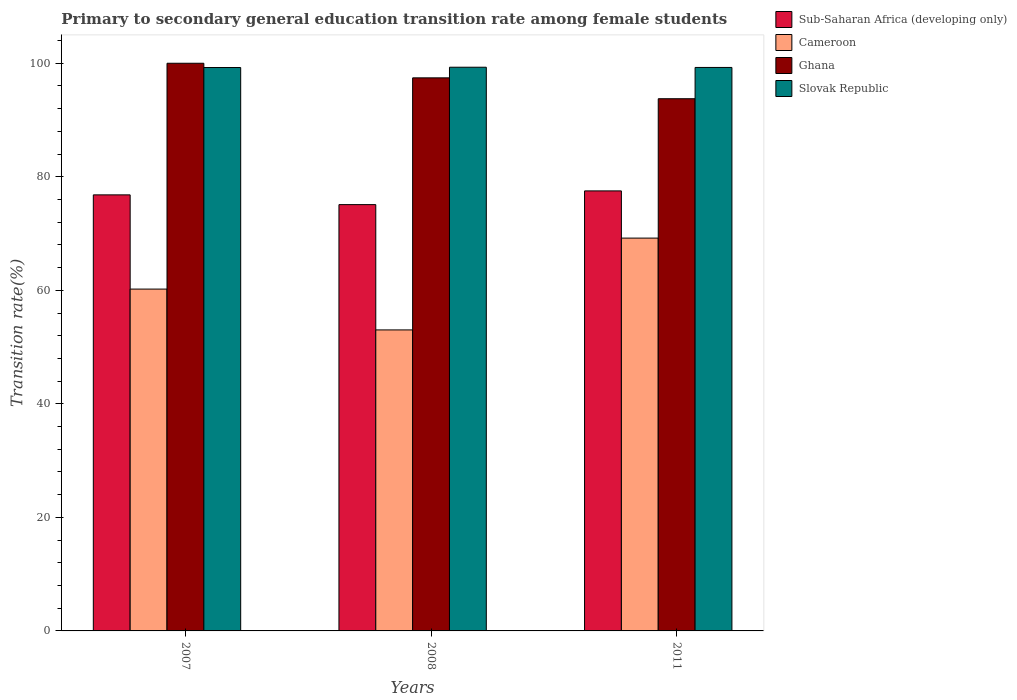How many different coloured bars are there?
Make the answer very short. 4. How many groups of bars are there?
Your answer should be compact. 3. Are the number of bars per tick equal to the number of legend labels?
Ensure brevity in your answer.  Yes. How many bars are there on the 3rd tick from the right?
Offer a very short reply. 4. What is the transition rate in Sub-Saharan Africa (developing only) in 2007?
Give a very brief answer. 76.81. Across all years, what is the maximum transition rate in Cameroon?
Your answer should be very brief. 69.2. Across all years, what is the minimum transition rate in Slovak Republic?
Provide a short and direct response. 99.25. In which year was the transition rate in Sub-Saharan Africa (developing only) minimum?
Make the answer very short. 2008. What is the total transition rate in Cameroon in the graph?
Your answer should be very brief. 182.44. What is the difference between the transition rate in Slovak Republic in 2008 and that in 2011?
Your answer should be very brief. 0.04. What is the difference between the transition rate in Slovak Republic in 2007 and the transition rate in Cameroon in 2008?
Give a very brief answer. 46.22. What is the average transition rate in Cameroon per year?
Give a very brief answer. 60.81. In the year 2007, what is the difference between the transition rate in Slovak Republic and transition rate in Ghana?
Offer a terse response. -0.75. In how many years, is the transition rate in Sub-Saharan Africa (developing only) greater than 24 %?
Give a very brief answer. 3. What is the ratio of the transition rate in Cameroon in 2008 to that in 2011?
Offer a terse response. 0.77. Is the transition rate in Slovak Republic in 2007 less than that in 2011?
Your answer should be very brief. Yes. Is the difference between the transition rate in Slovak Republic in 2008 and 2011 greater than the difference between the transition rate in Ghana in 2008 and 2011?
Make the answer very short. No. What is the difference between the highest and the second highest transition rate in Slovak Republic?
Keep it short and to the point. 0.04. What is the difference between the highest and the lowest transition rate in Cameroon?
Provide a short and direct response. 16.17. What does the 4th bar from the left in 2011 represents?
Keep it short and to the point. Slovak Republic. What is the difference between two consecutive major ticks on the Y-axis?
Your response must be concise. 20. Does the graph contain any zero values?
Provide a short and direct response. No. What is the title of the graph?
Your answer should be very brief. Primary to secondary general education transition rate among female students. Does "Arab World" appear as one of the legend labels in the graph?
Make the answer very short. No. What is the label or title of the X-axis?
Your answer should be compact. Years. What is the label or title of the Y-axis?
Your response must be concise. Transition rate(%). What is the Transition rate(%) of Sub-Saharan Africa (developing only) in 2007?
Provide a succinct answer. 76.81. What is the Transition rate(%) of Cameroon in 2007?
Provide a succinct answer. 60.22. What is the Transition rate(%) in Slovak Republic in 2007?
Keep it short and to the point. 99.25. What is the Transition rate(%) in Sub-Saharan Africa (developing only) in 2008?
Keep it short and to the point. 75.1. What is the Transition rate(%) of Cameroon in 2008?
Keep it short and to the point. 53.03. What is the Transition rate(%) of Ghana in 2008?
Provide a short and direct response. 97.43. What is the Transition rate(%) in Slovak Republic in 2008?
Offer a terse response. 99.3. What is the Transition rate(%) of Sub-Saharan Africa (developing only) in 2011?
Offer a terse response. 77.51. What is the Transition rate(%) of Cameroon in 2011?
Give a very brief answer. 69.2. What is the Transition rate(%) of Ghana in 2011?
Provide a succinct answer. 93.75. What is the Transition rate(%) in Slovak Republic in 2011?
Give a very brief answer. 99.26. Across all years, what is the maximum Transition rate(%) of Sub-Saharan Africa (developing only)?
Provide a short and direct response. 77.51. Across all years, what is the maximum Transition rate(%) in Cameroon?
Make the answer very short. 69.2. Across all years, what is the maximum Transition rate(%) of Ghana?
Offer a very short reply. 100. Across all years, what is the maximum Transition rate(%) of Slovak Republic?
Offer a very short reply. 99.3. Across all years, what is the minimum Transition rate(%) of Sub-Saharan Africa (developing only)?
Your answer should be compact. 75.1. Across all years, what is the minimum Transition rate(%) in Cameroon?
Keep it short and to the point. 53.03. Across all years, what is the minimum Transition rate(%) of Ghana?
Give a very brief answer. 93.75. Across all years, what is the minimum Transition rate(%) of Slovak Republic?
Offer a very short reply. 99.25. What is the total Transition rate(%) of Sub-Saharan Africa (developing only) in the graph?
Ensure brevity in your answer.  229.43. What is the total Transition rate(%) of Cameroon in the graph?
Your answer should be compact. 182.44. What is the total Transition rate(%) in Ghana in the graph?
Ensure brevity in your answer.  291.18. What is the total Transition rate(%) in Slovak Republic in the graph?
Offer a terse response. 297.81. What is the difference between the Transition rate(%) in Sub-Saharan Africa (developing only) in 2007 and that in 2008?
Keep it short and to the point. 1.72. What is the difference between the Transition rate(%) of Cameroon in 2007 and that in 2008?
Your answer should be very brief. 7.19. What is the difference between the Transition rate(%) in Ghana in 2007 and that in 2008?
Your answer should be very brief. 2.57. What is the difference between the Transition rate(%) of Slovak Republic in 2007 and that in 2008?
Your answer should be compact. -0.05. What is the difference between the Transition rate(%) in Sub-Saharan Africa (developing only) in 2007 and that in 2011?
Make the answer very short. -0.7. What is the difference between the Transition rate(%) in Cameroon in 2007 and that in 2011?
Your answer should be very brief. -8.98. What is the difference between the Transition rate(%) in Ghana in 2007 and that in 2011?
Keep it short and to the point. 6.25. What is the difference between the Transition rate(%) in Slovak Republic in 2007 and that in 2011?
Offer a terse response. -0.01. What is the difference between the Transition rate(%) of Sub-Saharan Africa (developing only) in 2008 and that in 2011?
Offer a very short reply. -2.42. What is the difference between the Transition rate(%) of Cameroon in 2008 and that in 2011?
Ensure brevity in your answer.  -16.17. What is the difference between the Transition rate(%) in Ghana in 2008 and that in 2011?
Ensure brevity in your answer.  3.68. What is the difference between the Transition rate(%) of Slovak Republic in 2008 and that in 2011?
Your answer should be very brief. 0.04. What is the difference between the Transition rate(%) of Sub-Saharan Africa (developing only) in 2007 and the Transition rate(%) of Cameroon in 2008?
Your answer should be compact. 23.79. What is the difference between the Transition rate(%) in Sub-Saharan Africa (developing only) in 2007 and the Transition rate(%) in Ghana in 2008?
Keep it short and to the point. -20.62. What is the difference between the Transition rate(%) of Sub-Saharan Africa (developing only) in 2007 and the Transition rate(%) of Slovak Republic in 2008?
Ensure brevity in your answer.  -22.49. What is the difference between the Transition rate(%) in Cameroon in 2007 and the Transition rate(%) in Ghana in 2008?
Keep it short and to the point. -37.21. What is the difference between the Transition rate(%) in Cameroon in 2007 and the Transition rate(%) in Slovak Republic in 2008?
Make the answer very short. -39.08. What is the difference between the Transition rate(%) in Ghana in 2007 and the Transition rate(%) in Slovak Republic in 2008?
Your response must be concise. 0.7. What is the difference between the Transition rate(%) of Sub-Saharan Africa (developing only) in 2007 and the Transition rate(%) of Cameroon in 2011?
Give a very brief answer. 7.62. What is the difference between the Transition rate(%) in Sub-Saharan Africa (developing only) in 2007 and the Transition rate(%) in Ghana in 2011?
Keep it short and to the point. -16.94. What is the difference between the Transition rate(%) of Sub-Saharan Africa (developing only) in 2007 and the Transition rate(%) of Slovak Republic in 2011?
Your answer should be very brief. -22.45. What is the difference between the Transition rate(%) of Cameroon in 2007 and the Transition rate(%) of Ghana in 2011?
Give a very brief answer. -33.53. What is the difference between the Transition rate(%) of Cameroon in 2007 and the Transition rate(%) of Slovak Republic in 2011?
Offer a very short reply. -39.04. What is the difference between the Transition rate(%) in Ghana in 2007 and the Transition rate(%) in Slovak Republic in 2011?
Your response must be concise. 0.74. What is the difference between the Transition rate(%) of Sub-Saharan Africa (developing only) in 2008 and the Transition rate(%) of Cameroon in 2011?
Your answer should be very brief. 5.9. What is the difference between the Transition rate(%) of Sub-Saharan Africa (developing only) in 2008 and the Transition rate(%) of Ghana in 2011?
Your answer should be very brief. -18.66. What is the difference between the Transition rate(%) in Sub-Saharan Africa (developing only) in 2008 and the Transition rate(%) in Slovak Republic in 2011?
Keep it short and to the point. -24.17. What is the difference between the Transition rate(%) in Cameroon in 2008 and the Transition rate(%) in Ghana in 2011?
Give a very brief answer. -40.73. What is the difference between the Transition rate(%) of Cameroon in 2008 and the Transition rate(%) of Slovak Republic in 2011?
Ensure brevity in your answer.  -46.24. What is the difference between the Transition rate(%) of Ghana in 2008 and the Transition rate(%) of Slovak Republic in 2011?
Your answer should be very brief. -1.83. What is the average Transition rate(%) in Sub-Saharan Africa (developing only) per year?
Your answer should be very brief. 76.47. What is the average Transition rate(%) of Cameroon per year?
Provide a succinct answer. 60.81. What is the average Transition rate(%) in Ghana per year?
Offer a very short reply. 97.06. What is the average Transition rate(%) in Slovak Republic per year?
Keep it short and to the point. 99.27. In the year 2007, what is the difference between the Transition rate(%) of Sub-Saharan Africa (developing only) and Transition rate(%) of Cameroon?
Keep it short and to the point. 16.6. In the year 2007, what is the difference between the Transition rate(%) in Sub-Saharan Africa (developing only) and Transition rate(%) in Ghana?
Make the answer very short. -23.19. In the year 2007, what is the difference between the Transition rate(%) of Sub-Saharan Africa (developing only) and Transition rate(%) of Slovak Republic?
Offer a very short reply. -22.43. In the year 2007, what is the difference between the Transition rate(%) of Cameroon and Transition rate(%) of Ghana?
Your response must be concise. -39.78. In the year 2007, what is the difference between the Transition rate(%) of Cameroon and Transition rate(%) of Slovak Republic?
Your answer should be very brief. -39.03. In the year 2007, what is the difference between the Transition rate(%) of Ghana and Transition rate(%) of Slovak Republic?
Your answer should be very brief. 0.75. In the year 2008, what is the difference between the Transition rate(%) of Sub-Saharan Africa (developing only) and Transition rate(%) of Cameroon?
Ensure brevity in your answer.  22.07. In the year 2008, what is the difference between the Transition rate(%) in Sub-Saharan Africa (developing only) and Transition rate(%) in Ghana?
Your response must be concise. -22.33. In the year 2008, what is the difference between the Transition rate(%) in Sub-Saharan Africa (developing only) and Transition rate(%) in Slovak Republic?
Provide a succinct answer. -24.2. In the year 2008, what is the difference between the Transition rate(%) of Cameroon and Transition rate(%) of Ghana?
Your answer should be very brief. -44.4. In the year 2008, what is the difference between the Transition rate(%) of Cameroon and Transition rate(%) of Slovak Republic?
Give a very brief answer. -46.27. In the year 2008, what is the difference between the Transition rate(%) of Ghana and Transition rate(%) of Slovak Republic?
Provide a short and direct response. -1.87. In the year 2011, what is the difference between the Transition rate(%) of Sub-Saharan Africa (developing only) and Transition rate(%) of Cameroon?
Give a very brief answer. 8.32. In the year 2011, what is the difference between the Transition rate(%) in Sub-Saharan Africa (developing only) and Transition rate(%) in Ghana?
Give a very brief answer. -16.24. In the year 2011, what is the difference between the Transition rate(%) of Sub-Saharan Africa (developing only) and Transition rate(%) of Slovak Republic?
Provide a short and direct response. -21.75. In the year 2011, what is the difference between the Transition rate(%) in Cameroon and Transition rate(%) in Ghana?
Your response must be concise. -24.55. In the year 2011, what is the difference between the Transition rate(%) of Cameroon and Transition rate(%) of Slovak Republic?
Offer a terse response. -30.06. In the year 2011, what is the difference between the Transition rate(%) in Ghana and Transition rate(%) in Slovak Republic?
Provide a short and direct response. -5.51. What is the ratio of the Transition rate(%) of Sub-Saharan Africa (developing only) in 2007 to that in 2008?
Give a very brief answer. 1.02. What is the ratio of the Transition rate(%) of Cameroon in 2007 to that in 2008?
Provide a short and direct response. 1.14. What is the ratio of the Transition rate(%) in Ghana in 2007 to that in 2008?
Keep it short and to the point. 1.03. What is the ratio of the Transition rate(%) in Cameroon in 2007 to that in 2011?
Give a very brief answer. 0.87. What is the ratio of the Transition rate(%) of Ghana in 2007 to that in 2011?
Offer a very short reply. 1.07. What is the ratio of the Transition rate(%) in Sub-Saharan Africa (developing only) in 2008 to that in 2011?
Give a very brief answer. 0.97. What is the ratio of the Transition rate(%) of Cameroon in 2008 to that in 2011?
Your response must be concise. 0.77. What is the ratio of the Transition rate(%) of Ghana in 2008 to that in 2011?
Keep it short and to the point. 1.04. What is the difference between the highest and the second highest Transition rate(%) of Sub-Saharan Africa (developing only)?
Offer a very short reply. 0.7. What is the difference between the highest and the second highest Transition rate(%) of Cameroon?
Offer a terse response. 8.98. What is the difference between the highest and the second highest Transition rate(%) of Ghana?
Ensure brevity in your answer.  2.57. What is the difference between the highest and the second highest Transition rate(%) of Slovak Republic?
Your response must be concise. 0.04. What is the difference between the highest and the lowest Transition rate(%) of Sub-Saharan Africa (developing only)?
Make the answer very short. 2.42. What is the difference between the highest and the lowest Transition rate(%) of Cameroon?
Give a very brief answer. 16.17. What is the difference between the highest and the lowest Transition rate(%) in Ghana?
Offer a terse response. 6.25. What is the difference between the highest and the lowest Transition rate(%) of Slovak Republic?
Keep it short and to the point. 0.05. 